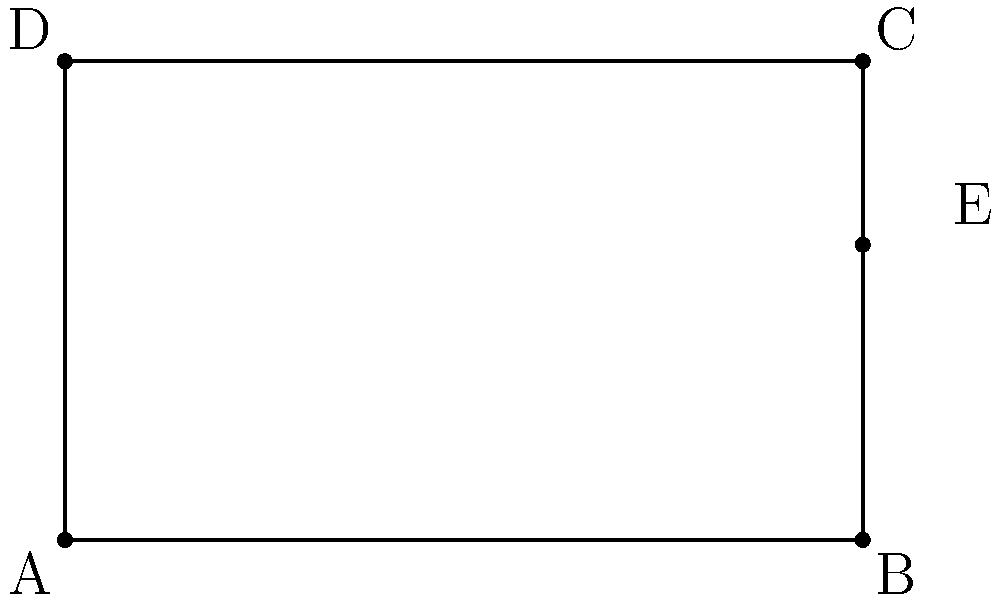In character design, the golden ratio is often used to create aesthetically pleasing proportions. Consider the diagram representing a character's face, where rectangle ABCD represents the entire face, and point E divides the face vertically according to the golden ratio. If the width of the face (AB) is 5 units and the total height (AD) is 3 units, what is the distance BE (rounded to two decimal places)? To solve this problem, we'll use the properties of the golden ratio and basic geometry:

1) The golden ratio is approximately 1.618034, often denoted by the Greek letter φ (phi).

2) In the context of the face, the ratio of the whole (AB) to the larger part (BE) should equal the ratio of the larger part (BE) to the smaller part (EC).

3) Let x be the length of BE. Then:

   $\frac{AB}{BE} = \frac{BE}{EC}$

   $\frac{5}{x} = \frac{x}{5-x}$

4) Cross-multiply:

   $5(5-x) = x^2$

5) Expand:

   $25 - 5x = x^2$

6) Rearrange:

   $x^2 + 5x - 25 = 0$

7) This is a quadratic equation. We can solve it using the quadratic formula:

   $x = \frac{-b \pm \sqrt{b^2 - 4ac}}{2a}$

   Where $a=1$, $b=5$, and $c=-25$

8) Plugging in these values:

   $x = \frac{-5 \pm \sqrt{25 + 100}}{2} = \frac{-5 \pm \sqrt{125}}{2}$

9) Simplify:

   $x = \frac{-5 \pm 5\sqrt{5}}{2}$

10) We only need the positive solution:

    $x = \frac{-5 + 5\sqrt{5}}{2}$

11) Calculate and round to two decimal places:

    $x \approx 3.09$

Therefore, the distance BE is approximately 3.09 units.
Answer: 3.09 units 